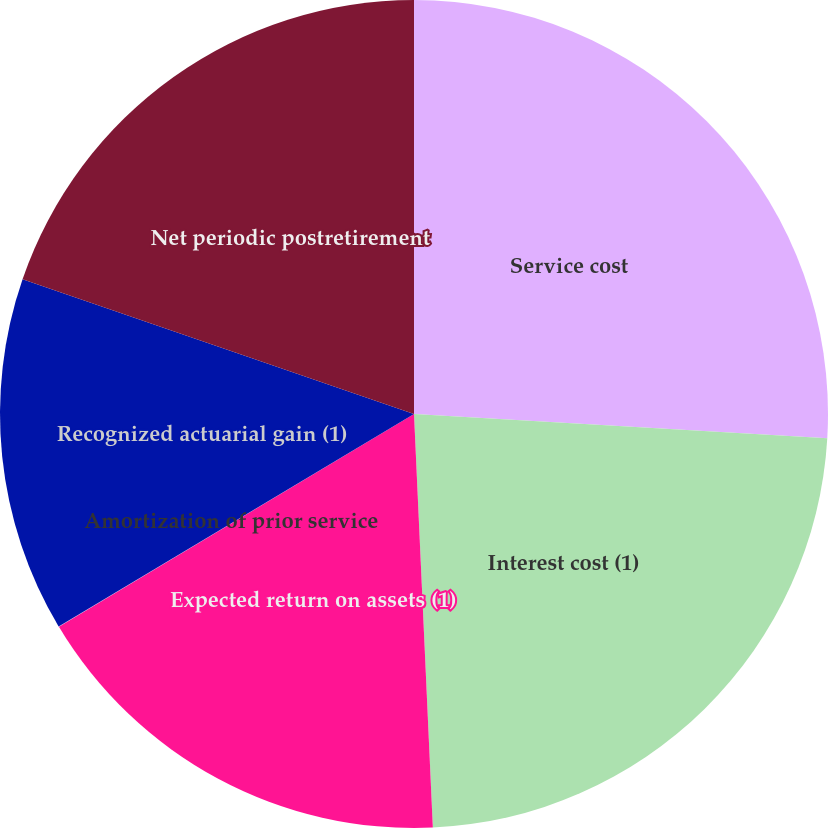<chart> <loc_0><loc_0><loc_500><loc_500><pie_chart><fcel>Service cost<fcel>Interest cost (1)<fcel>Expected return on assets (1)<fcel>Amortization of prior service<fcel>Recognized actuarial gain (1)<fcel>Net periodic postretirement<nl><fcel>25.93%<fcel>23.34%<fcel>17.13%<fcel>0.02%<fcel>13.85%<fcel>19.72%<nl></chart> 